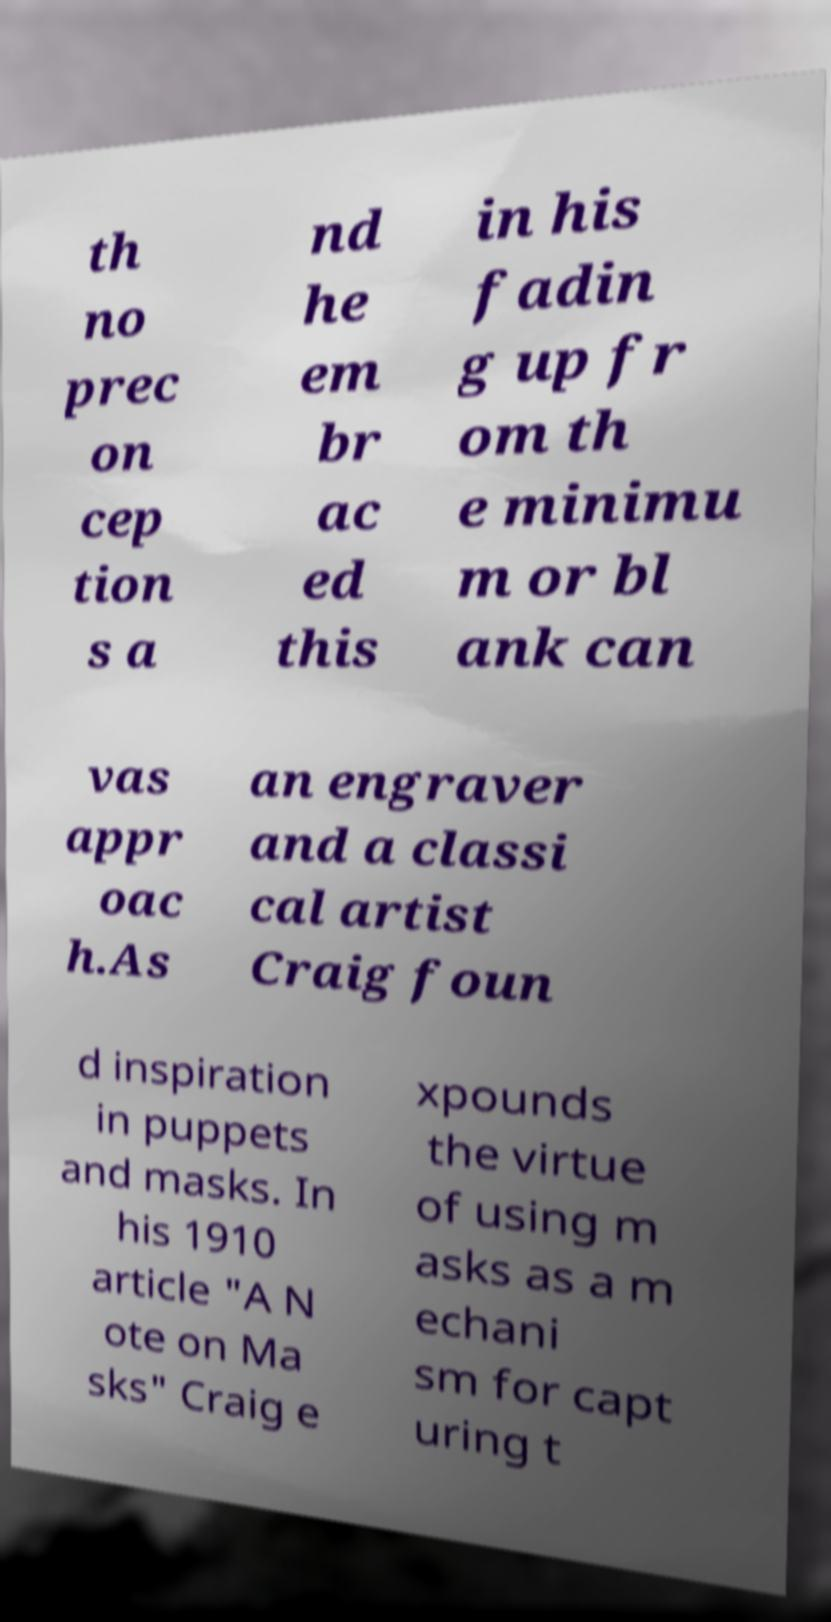There's text embedded in this image that I need extracted. Can you transcribe it verbatim? th no prec on cep tion s a nd he em br ac ed this in his fadin g up fr om th e minimu m or bl ank can vas appr oac h.As an engraver and a classi cal artist Craig foun d inspiration in puppets and masks. In his 1910 article "A N ote on Ma sks" Craig e xpounds the virtue of using m asks as a m echani sm for capt uring t 